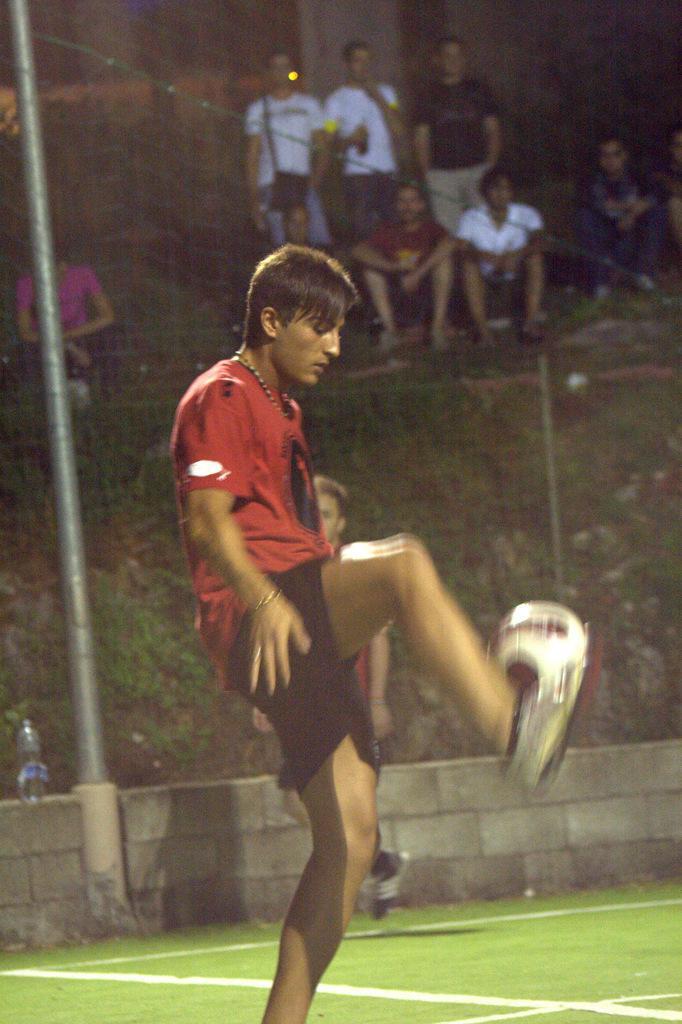How would you summarize this image in a sentence or two? The person wearing red shirt is playing football and there are group of people behind him and the ground is greenery. 